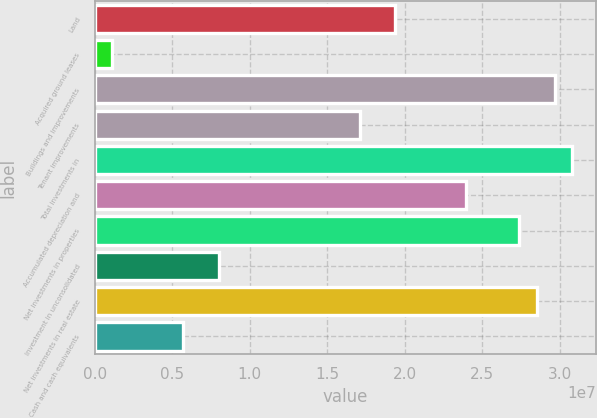Convert chart. <chart><loc_0><loc_0><loc_500><loc_500><bar_chart><fcel>Land<fcel>Acquired ground leases<fcel>Buildings and improvements<fcel>Tenant improvements<fcel>Total investments in<fcel>Accumulated depreciation and<fcel>Net investments in properties<fcel>Investment in unconsolidated<fcel>Net investments in real estate<fcel>Cash and cash equivalents<nl><fcel>1.94033e+07<fcel>1.14682e+06<fcel>2.96725e+07<fcel>1.71212e+07<fcel>3.08135e+07<fcel>2.39674e+07<fcel>2.73904e+07<fcel>7.99298e+06<fcel>2.85315e+07<fcel>5.71093e+06<nl></chart> 